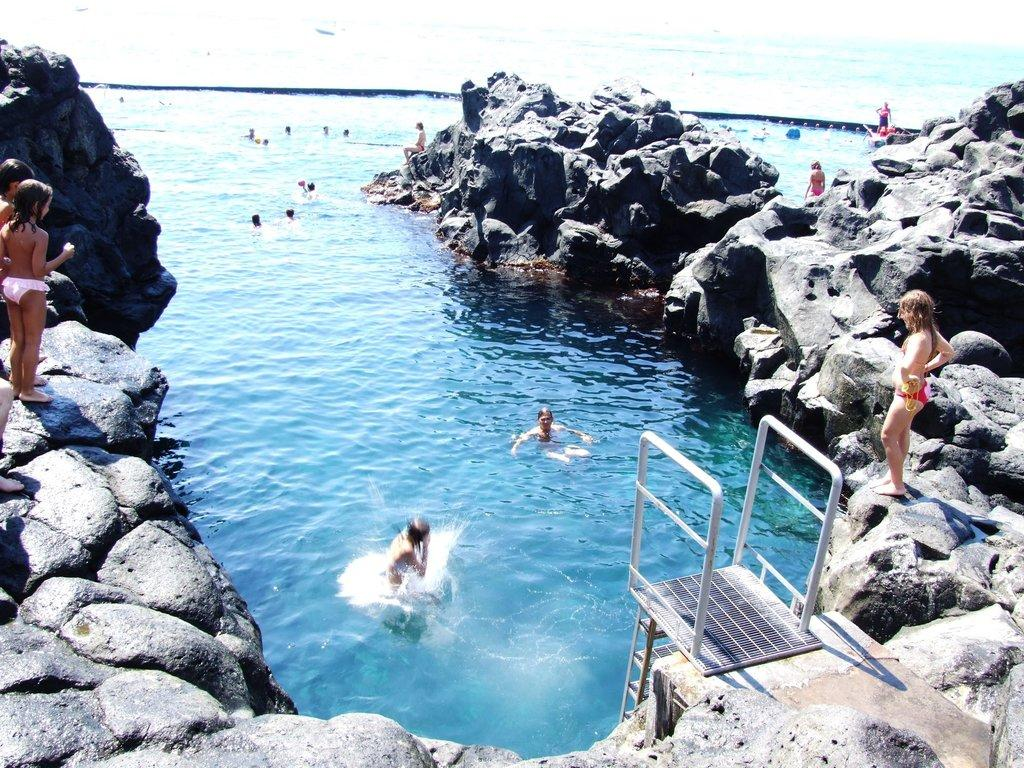What are the people in the image doing? The people in the image are swimming in the water. Are there any people not swimming in the image? Yes, there are people standing on a rock in the image. What can be seen in the image that might be used for climbing or accessing the water? A ladder is visible in the image. What type of development can be seen in the image? There is no development, such as buildings or infrastructure, present in the image. The focus is on the people and the water. 